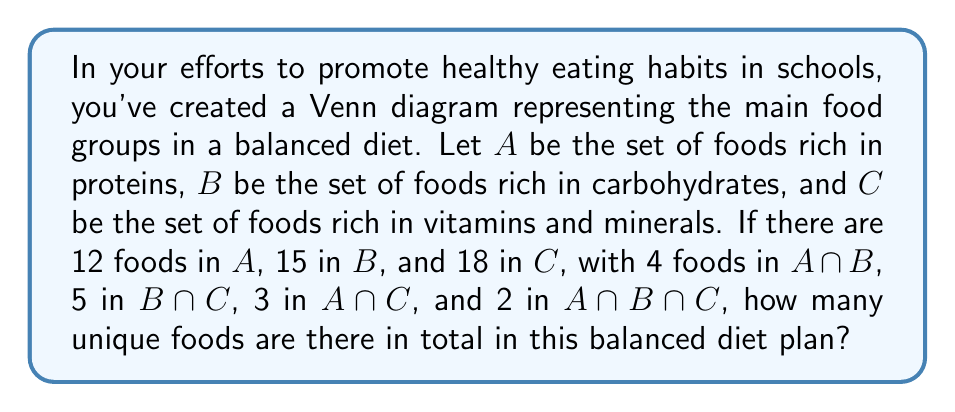Could you help me with this problem? Let's solve this step-by-step using the principle of inclusion-exclusion:

1) First, let's define the universal set U as the set of all unique foods in the diet plan.

2) We need to find |U| = |A ∪ B ∪ C|

3) The principle of inclusion-exclusion states:
   $$|A ∪ B ∪ C| = |A| + |B| + |C| - |A ∩ B| - |B ∩ C| - |A ∩ C| + |A ∩ B ∩ C|$$

4) We know:
   |A| = 12, |B| = 15, |C| = 18
   |A ∩ B| = 4, |B ∩ C| = 5, |A ∩ C| = 3
   |A ∩ B ∩ C| = 2

5) Let's substitute these values into the equation:
   $$|U| = 12 + 15 + 18 - 4 - 5 - 3 + 2$$

6) Simplifying:
   $$|U| = 45 - 12 + 2 = 35$$

Therefore, there are 35 unique foods in total in this balanced diet plan.
Answer: 35 